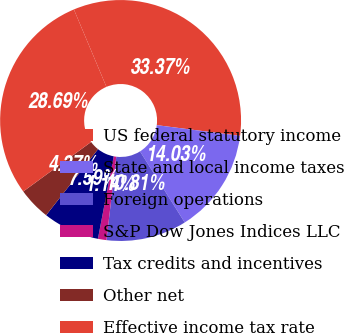Convert chart to OTSL. <chart><loc_0><loc_0><loc_500><loc_500><pie_chart><fcel>US federal statutory income<fcel>State and local income taxes<fcel>Foreign operations<fcel>S&P Dow Jones Indices LLC<fcel>Tax credits and incentives<fcel>Other net<fcel>Effective income tax rate<nl><fcel>33.37%<fcel>14.03%<fcel>10.81%<fcel>1.14%<fcel>7.59%<fcel>4.37%<fcel>28.69%<nl></chart> 